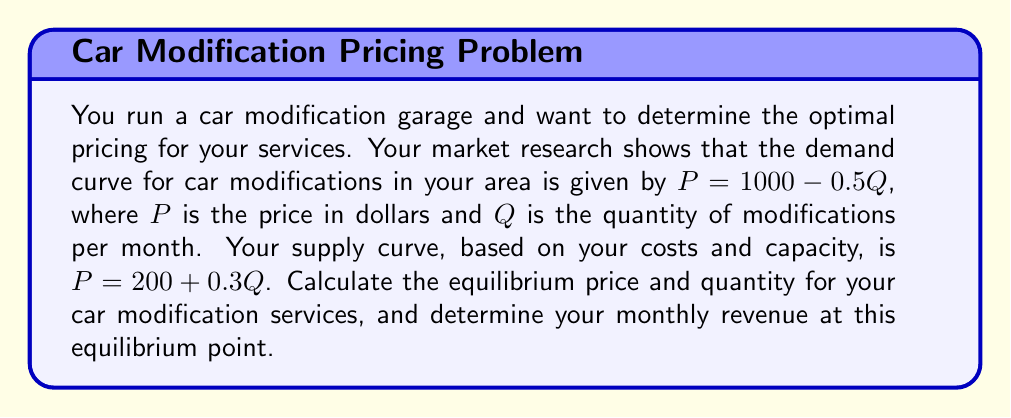Can you answer this question? To solve this problem, we'll follow these steps:

1) Find the equilibrium point by equating the demand and supply curves:

   Demand: $P = 1000 - 0.5Q$
   Supply: $P = 200 + 0.3Q$

   At equilibrium: $1000 - 0.5Q = 200 + 0.3Q$

2) Solve for Q:

   $1000 - 200 = 0.3Q + 0.5Q$
   $800 = 0.8Q$
   $Q = 1000$

3) Substitute Q back into either the demand or supply equation to find P:

   $P = 1000 - 0.5(1000) = 500$

   or

   $P = 200 + 0.3(1000) = 500$

4) Calculate the monthly revenue at equilibrium:

   Revenue = Price * Quantity
   $R = P * Q = 500 * 1000 = 500,000$

Therefore, the equilibrium price is $500, the equilibrium quantity is 1000 modifications per month, and the monthly revenue at this equilibrium point is $500,000.

[asy]
import graph;
size(200,200);
real f(real x) {return 1000-0.5x;}
real g(real x) {return 200+0.3x;}
draw(graph(f,0,2000),blue);
draw(graph(g,0,2000),red);
xaxis("Q",0,2000,arrow=Arrow);
yaxis("P",0,1000,arrow=Arrow);
label("Demand",(-10,1000),blue);
label("Supply",(2000,800),red);
dot((1000,500));
label("Equilibrium",(1000,500),NE);
[/asy]
Answer: The equilibrium price is $500, the equilibrium quantity is 1000 modifications per month, and the monthly revenue at this equilibrium point is $500,000. 